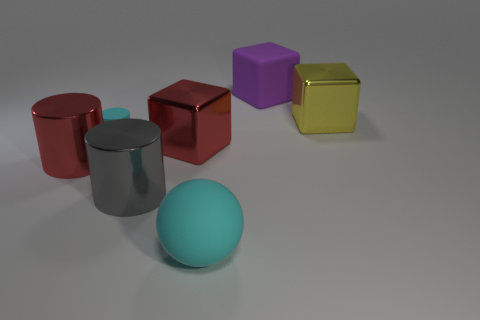Subtract all large metal cylinders. How many cylinders are left? 1 Add 1 rubber spheres. How many objects exist? 8 Subtract all cylinders. How many objects are left? 4 Add 1 big gray metal things. How many big gray metal things exist? 2 Subtract 0 blue blocks. How many objects are left? 7 Subtract all gray cylinders. Subtract all purple balls. How many cylinders are left? 2 Subtract all big purple metal cylinders. Subtract all large gray metal things. How many objects are left? 6 Add 4 large cyan objects. How many large cyan objects are left? 5 